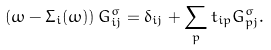Convert formula to latex. <formula><loc_0><loc_0><loc_500><loc_500>\left ( \omega - \Sigma _ { i } ( \omega ) \right ) G _ { i j } ^ { \sigma } = \delta _ { i j } + \sum _ { p } t _ { i p } G _ { p j } ^ { \sigma } .</formula> 